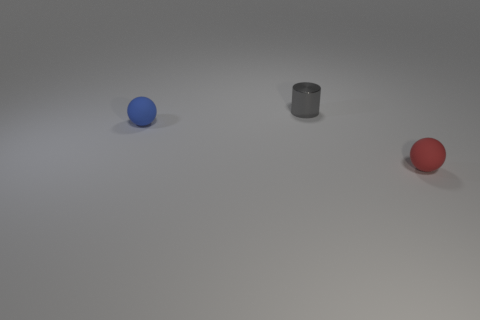Are there any other things that have the same material as the tiny gray thing?
Give a very brief answer. No. Does the object on the left side of the tiny cylinder have the same material as the object behind the tiny blue rubber thing?
Offer a terse response. No. There is a tiny shiny object; is its shape the same as the small matte thing in front of the blue rubber ball?
Make the answer very short. No. What number of tiny things are either red rubber spheres or rubber things?
Provide a succinct answer. 2. What is the color of the rubber object that is on the left side of the small rubber sphere that is right of the shiny cylinder?
Offer a very short reply. Blue. Do the tiny gray cylinder and the tiny ball that is to the left of the small gray metallic thing have the same material?
Ensure brevity in your answer.  No. There is a ball behind the red ball; what material is it?
Your response must be concise. Rubber. Are there the same number of cylinders left of the blue object and rubber balls?
Provide a short and direct response. No. Are there any other things that are the same size as the cylinder?
Provide a short and direct response. Yes. What is the material of the object in front of the small rubber thing behind the tiny red matte sphere?
Give a very brief answer. Rubber. 